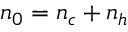<formula> <loc_0><loc_0><loc_500><loc_500>n _ { 0 } = n _ { c } + n _ { h }</formula> 